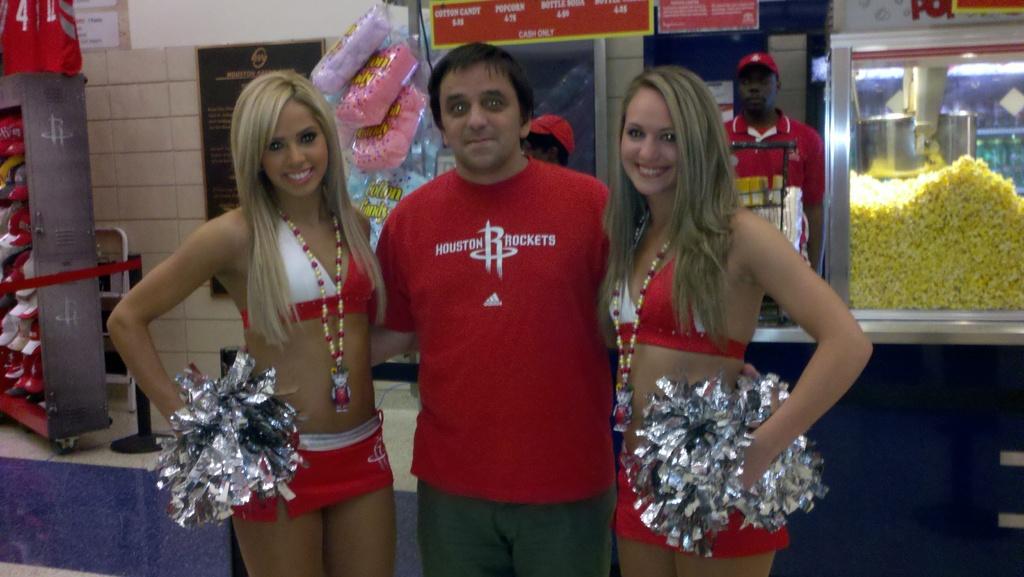What city is on his shirt?
Provide a short and direct response. Houston. 